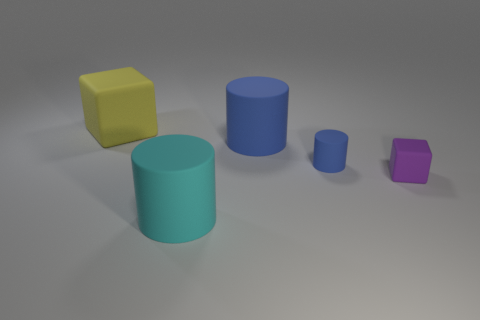Subtract all blue cylinders. How many cylinders are left? 1 Add 4 big blue cylinders. How many objects exist? 9 Subtract 1 cylinders. How many cylinders are left? 2 Subtract all purple blocks. How many blocks are left? 1 Subtract 1 purple blocks. How many objects are left? 4 Subtract all blocks. How many objects are left? 3 Subtract all purple cylinders. Subtract all cyan balls. How many cylinders are left? 3 Subtract all green spheres. How many cyan cubes are left? 0 Subtract all brown balls. Subtract all small cubes. How many objects are left? 4 Add 5 matte cylinders. How many matte cylinders are left? 8 